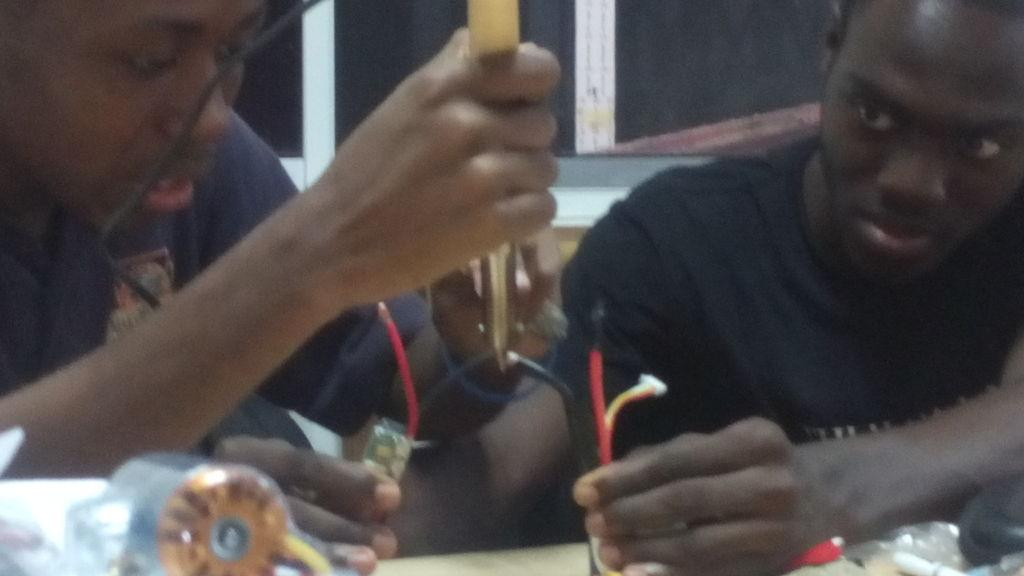How many people are in the image? There are two people in the image. What are the people wearing? The people are wearing t-shirts. What are the people holding in their hands? The people are holding wires and electronic devices. What else can be seen on the table in the image? There are electronic items on the table. Can you see the people shaking hands in the image? No, there is no indication that the people are shaking hands in the image. Is there a sea visible in the background of the image? No, there is no sea present in the image. 